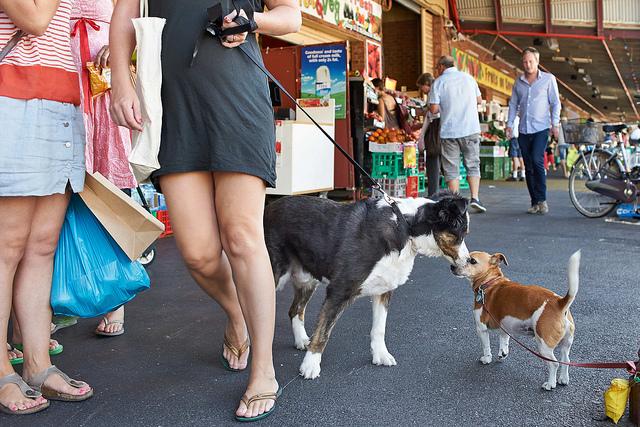Who is holding a paper bag?
Keep it brief. Woman. Are the dogs friends?
Concise answer only. Yes. Are the women wearing pants?
Be succinct. No. 